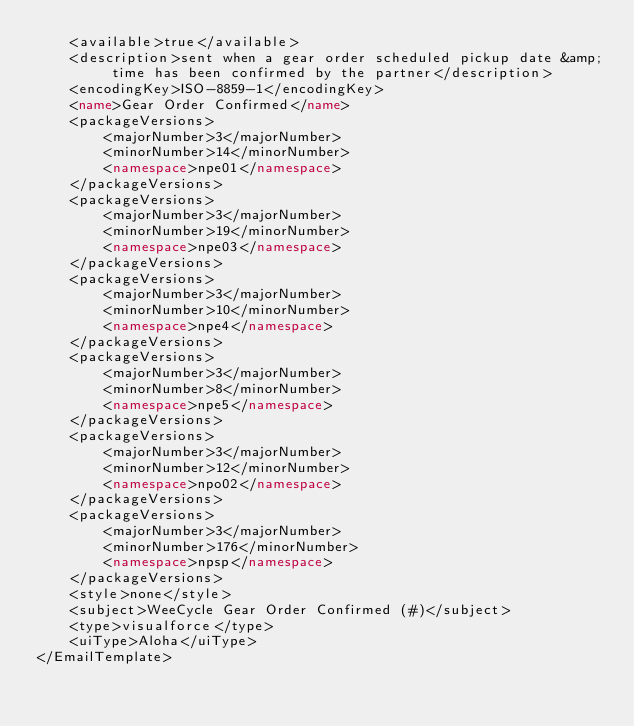Convert code to text. <code><loc_0><loc_0><loc_500><loc_500><_XML_>    <available>true</available>
    <description>sent when a gear order scheduled pickup date &amp; time has been confirmed by the partner</description>
    <encodingKey>ISO-8859-1</encodingKey>
    <name>Gear Order Confirmed</name>
    <packageVersions>
        <majorNumber>3</majorNumber>
        <minorNumber>14</minorNumber>
        <namespace>npe01</namespace>
    </packageVersions>
    <packageVersions>
        <majorNumber>3</majorNumber>
        <minorNumber>19</minorNumber>
        <namespace>npe03</namespace>
    </packageVersions>
    <packageVersions>
        <majorNumber>3</majorNumber>
        <minorNumber>10</minorNumber>
        <namespace>npe4</namespace>
    </packageVersions>
    <packageVersions>
        <majorNumber>3</majorNumber>
        <minorNumber>8</minorNumber>
        <namespace>npe5</namespace>
    </packageVersions>
    <packageVersions>
        <majorNumber>3</majorNumber>
        <minorNumber>12</minorNumber>
        <namespace>npo02</namespace>
    </packageVersions>
    <packageVersions>
        <majorNumber>3</majorNumber>
        <minorNumber>176</minorNumber>
        <namespace>npsp</namespace>
    </packageVersions>
    <style>none</style>
    <subject>WeeCycle Gear Order Confirmed (#)</subject>
    <type>visualforce</type>
    <uiType>Aloha</uiType>
</EmailTemplate>
</code> 